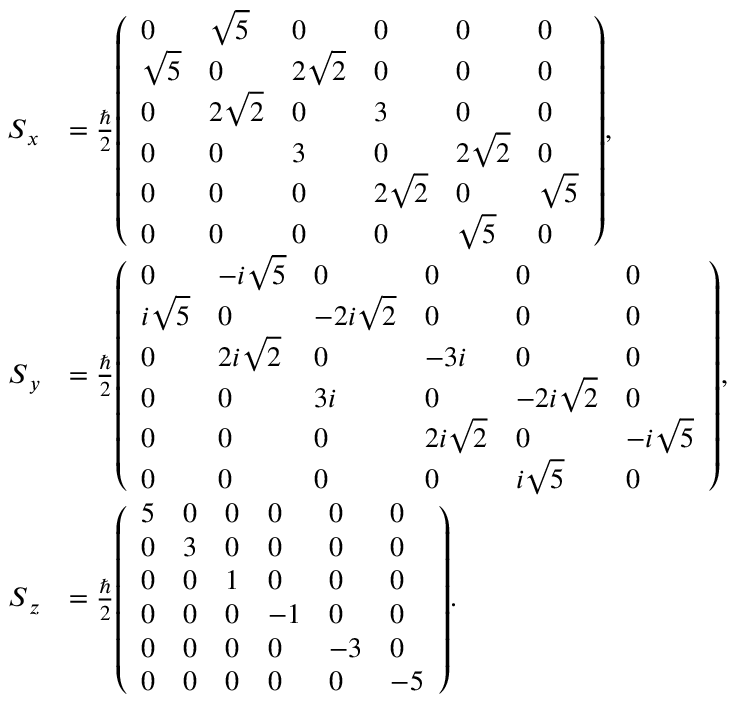<formula> <loc_0><loc_0><loc_500><loc_500>{ \begin{array} { r l } { { S } _ { x } } & { = { \frac { } { 2 } } { \left ( \begin{array} { l l l l l l } { 0 } & { { \sqrt { 5 } } } & { 0 } & { 0 } & { 0 } & { 0 } \\ { { \sqrt { 5 } } } & { 0 } & { 2 { \sqrt { 2 } } } & { 0 } & { 0 } & { 0 } \\ { 0 } & { 2 { \sqrt { 2 } } } & { 0 } & { 3 } & { 0 } & { 0 } \\ { 0 } & { 0 } & { 3 } & { 0 } & { 2 { \sqrt { 2 } } } & { 0 } \\ { 0 } & { 0 } & { 0 } & { 2 { \sqrt { 2 } } } & { 0 } & { { \sqrt { 5 } } } \\ { 0 } & { 0 } & { 0 } & { 0 } & { { \sqrt { 5 } } } & { 0 } \end{array} \right ) } , } \\ { { S } _ { y } } & { = { \frac { } { 2 } } { \left ( \begin{array} { l l l l l l } { 0 } & { - i { \sqrt { 5 } } } & { 0 } & { 0 } & { 0 } & { 0 } \\ { i { \sqrt { 5 } } } & { 0 } & { - 2 i { \sqrt { 2 } } } & { 0 } & { 0 } & { 0 } \\ { 0 } & { 2 i { \sqrt { 2 } } } & { 0 } & { - 3 i } & { 0 } & { 0 } \\ { 0 } & { 0 } & { 3 i } & { 0 } & { - 2 i { \sqrt { 2 } } } & { 0 } \\ { 0 } & { 0 } & { 0 } & { 2 i { \sqrt { 2 } } } & { 0 } & { - i { \sqrt { 5 } } } \\ { 0 } & { 0 } & { 0 } & { 0 } & { i { \sqrt { 5 } } } & { 0 } \end{array} \right ) } , } \\ { { S } _ { z } } & { = { \frac { } { 2 } } { \left ( \begin{array} { l l l l l l } { 5 } & { 0 } & { 0 } & { 0 } & { 0 } & { 0 } \\ { 0 } & { 3 } & { 0 } & { 0 } & { 0 } & { 0 } \\ { 0 } & { 0 } & { 1 } & { 0 } & { 0 } & { 0 } \\ { 0 } & { 0 } & { 0 } & { - 1 } & { 0 } & { 0 } \\ { 0 } & { 0 } & { 0 } & { 0 } & { - 3 } & { 0 } \\ { 0 } & { 0 } & { 0 } & { 0 } & { 0 } & { - 5 } \end{array} \right ) } . } \end{array} }</formula> 